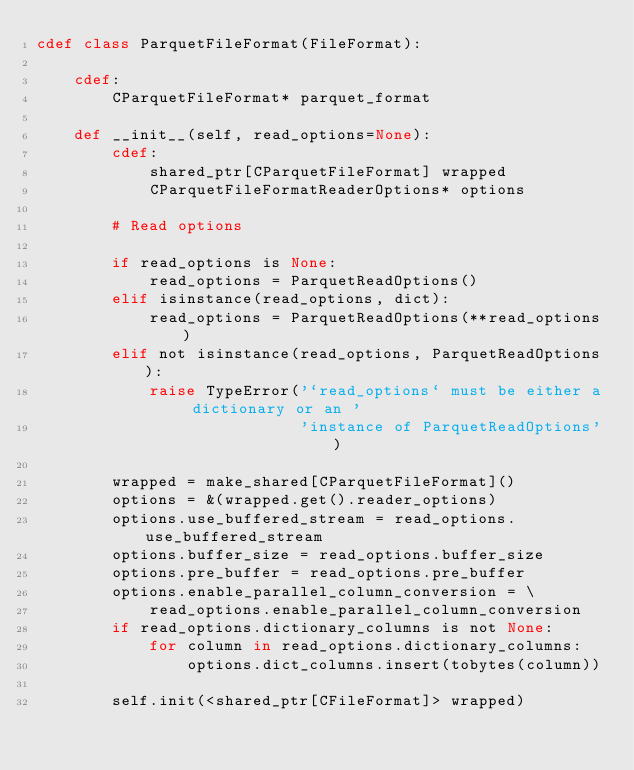Convert code to text. <code><loc_0><loc_0><loc_500><loc_500><_Cython_>cdef class ParquetFileFormat(FileFormat):

    cdef:
        CParquetFileFormat* parquet_format

    def __init__(self, read_options=None):
        cdef:
            shared_ptr[CParquetFileFormat] wrapped
            CParquetFileFormatReaderOptions* options

        # Read options

        if read_options is None:
            read_options = ParquetReadOptions()
        elif isinstance(read_options, dict):
            read_options = ParquetReadOptions(**read_options)
        elif not isinstance(read_options, ParquetReadOptions):
            raise TypeError('`read_options` must be either a dictionary or an '
                            'instance of ParquetReadOptions')

        wrapped = make_shared[CParquetFileFormat]()
        options = &(wrapped.get().reader_options)
        options.use_buffered_stream = read_options.use_buffered_stream
        options.buffer_size = read_options.buffer_size
        options.pre_buffer = read_options.pre_buffer
        options.enable_parallel_column_conversion = \
            read_options.enable_parallel_column_conversion
        if read_options.dictionary_columns is not None:
            for column in read_options.dictionary_columns:
                options.dict_columns.insert(tobytes(column))

        self.init(<shared_ptr[CFileFormat]> wrapped)
</code> 